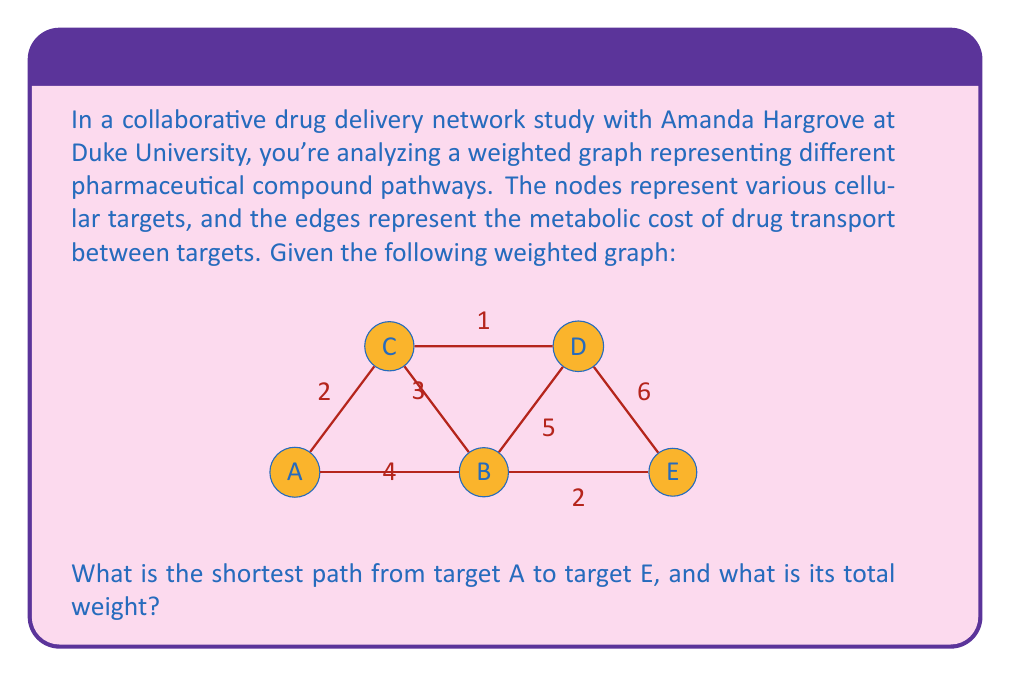Help me with this question. To solve this problem, we can use Dijkstra's algorithm, which is an efficient method for finding the shortest path in a weighted graph.

Let's apply Dijkstra's algorithm step by step:

1) Initialize:
   - Distance to A: 0
   - Distance to all other nodes: $\infty$
   - Set of unvisited nodes: {A, B, C, D, E}

2) Start from node A:
   - Update distances: 
     B: min($\infty$, 0 + 4) = 4
     C: min($\infty$, 0 + 2) = 2
   - Mark A as visited
   - Unvisited set: {B, C, D, E}

3) Select node with minimum distance (C):
   - Update distances:
     D: min($\infty$, 2 + 1) = 3
   - Mark C as visited
   - Unvisited set: {B, D, E}

4) Select node with minimum distance (D):
   - Update distances:
     E: min($\infty$, 3 + 6) = 9
     B: min(4, 3 + 5) = 4 (no change)
   - Mark D as visited
   - Unvisited set: {B, E}

5) Select node with minimum distance (B):
   - Update distances:
     E: min(9, 4 + 2) = 6
   - Mark B as visited
   - Unvisited set: {E}

6) Select node E (only remaining node):
   - Mark E as visited
   - Algorithm terminates

The shortest path from A to E is A -> B -> E with a total weight of 6.
Answer: The shortest path from target A to target E is A -> B -> E, with a total weight of 6. 